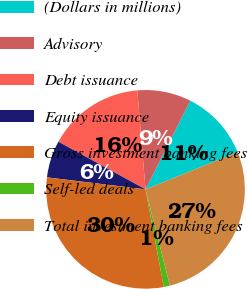<chart> <loc_0><loc_0><loc_500><loc_500><pie_chart><fcel>(Dollars in millions)<fcel>Advisory<fcel>Debt issuance<fcel>Equity issuance<fcel>Gross investment banking fees<fcel>Self-led deals<fcel>Total investment banking fees<nl><fcel>11.46%<fcel>8.75%<fcel>15.72%<fcel>6.03%<fcel>29.87%<fcel>1.01%<fcel>27.16%<nl></chart> 